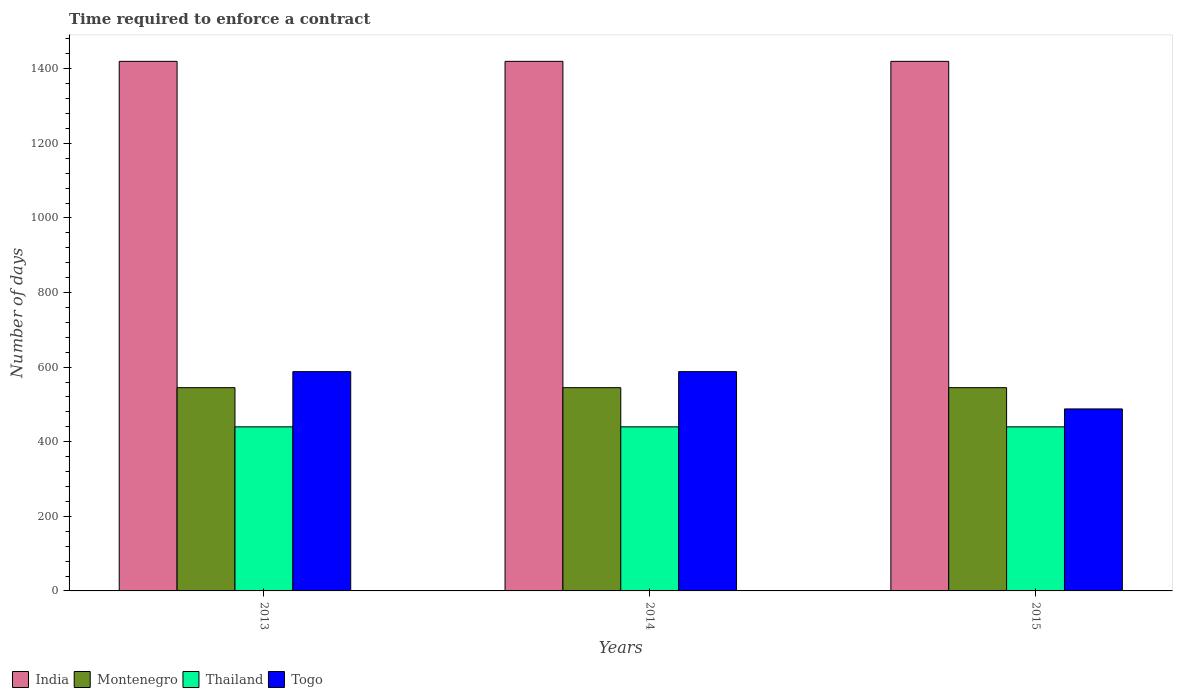How many groups of bars are there?
Your answer should be very brief. 3. Are the number of bars per tick equal to the number of legend labels?
Offer a very short reply. Yes. Are the number of bars on each tick of the X-axis equal?
Offer a very short reply. Yes. How many bars are there on the 3rd tick from the left?
Your response must be concise. 4. What is the label of the 3rd group of bars from the left?
Your answer should be compact. 2015. What is the number of days required to enforce a contract in India in 2015?
Ensure brevity in your answer.  1420. Across all years, what is the maximum number of days required to enforce a contract in Montenegro?
Your answer should be compact. 545. Across all years, what is the minimum number of days required to enforce a contract in Montenegro?
Make the answer very short. 545. In which year was the number of days required to enforce a contract in Thailand minimum?
Make the answer very short. 2013. What is the total number of days required to enforce a contract in India in the graph?
Ensure brevity in your answer.  4260. What is the difference between the number of days required to enforce a contract in Thailand in 2015 and the number of days required to enforce a contract in Togo in 2014?
Ensure brevity in your answer.  -148. What is the average number of days required to enforce a contract in Thailand per year?
Offer a very short reply. 440. In how many years, is the number of days required to enforce a contract in Togo greater than 1080 days?
Provide a short and direct response. 0. Is the number of days required to enforce a contract in Montenegro in 2013 less than that in 2014?
Make the answer very short. No. Is the difference between the number of days required to enforce a contract in Togo in 2013 and 2014 greater than the difference between the number of days required to enforce a contract in Montenegro in 2013 and 2014?
Provide a succinct answer. No. What is the difference between the highest and the lowest number of days required to enforce a contract in Montenegro?
Offer a very short reply. 0. In how many years, is the number of days required to enforce a contract in Thailand greater than the average number of days required to enforce a contract in Thailand taken over all years?
Offer a very short reply. 0. Is it the case that in every year, the sum of the number of days required to enforce a contract in Montenegro and number of days required to enforce a contract in Togo is greater than the sum of number of days required to enforce a contract in India and number of days required to enforce a contract in Thailand?
Make the answer very short. No. What does the 2nd bar from the left in 2013 represents?
Make the answer very short. Montenegro. What does the 2nd bar from the right in 2013 represents?
Keep it short and to the point. Thailand. Are all the bars in the graph horizontal?
Ensure brevity in your answer.  No. What is the difference between two consecutive major ticks on the Y-axis?
Keep it short and to the point. 200. Are the values on the major ticks of Y-axis written in scientific E-notation?
Offer a very short reply. No. Does the graph contain grids?
Provide a succinct answer. No. Where does the legend appear in the graph?
Provide a short and direct response. Bottom left. What is the title of the graph?
Provide a succinct answer. Time required to enforce a contract. What is the label or title of the X-axis?
Ensure brevity in your answer.  Years. What is the label or title of the Y-axis?
Your response must be concise. Number of days. What is the Number of days in India in 2013?
Make the answer very short. 1420. What is the Number of days of Montenegro in 2013?
Provide a short and direct response. 545. What is the Number of days in Thailand in 2013?
Offer a very short reply. 440. What is the Number of days in Togo in 2013?
Your answer should be very brief. 588. What is the Number of days of India in 2014?
Offer a terse response. 1420. What is the Number of days in Montenegro in 2014?
Your answer should be very brief. 545. What is the Number of days of Thailand in 2014?
Keep it short and to the point. 440. What is the Number of days in Togo in 2014?
Your answer should be very brief. 588. What is the Number of days in India in 2015?
Ensure brevity in your answer.  1420. What is the Number of days in Montenegro in 2015?
Offer a very short reply. 545. What is the Number of days in Thailand in 2015?
Make the answer very short. 440. What is the Number of days of Togo in 2015?
Offer a terse response. 488. Across all years, what is the maximum Number of days of India?
Your answer should be very brief. 1420. Across all years, what is the maximum Number of days of Montenegro?
Ensure brevity in your answer.  545. Across all years, what is the maximum Number of days in Thailand?
Your answer should be very brief. 440. Across all years, what is the maximum Number of days in Togo?
Make the answer very short. 588. Across all years, what is the minimum Number of days in India?
Ensure brevity in your answer.  1420. Across all years, what is the minimum Number of days of Montenegro?
Ensure brevity in your answer.  545. Across all years, what is the minimum Number of days in Thailand?
Offer a very short reply. 440. Across all years, what is the minimum Number of days in Togo?
Offer a very short reply. 488. What is the total Number of days of India in the graph?
Your answer should be very brief. 4260. What is the total Number of days of Montenegro in the graph?
Provide a succinct answer. 1635. What is the total Number of days of Thailand in the graph?
Give a very brief answer. 1320. What is the total Number of days of Togo in the graph?
Make the answer very short. 1664. What is the difference between the Number of days of India in 2013 and that in 2014?
Make the answer very short. 0. What is the difference between the Number of days of Thailand in 2013 and that in 2014?
Offer a very short reply. 0. What is the difference between the Number of days in Togo in 2013 and that in 2014?
Ensure brevity in your answer.  0. What is the difference between the Number of days in Montenegro in 2013 and that in 2015?
Your answer should be compact. 0. What is the difference between the Number of days of Togo in 2013 and that in 2015?
Your answer should be very brief. 100. What is the difference between the Number of days of India in 2014 and that in 2015?
Provide a short and direct response. 0. What is the difference between the Number of days of Togo in 2014 and that in 2015?
Offer a terse response. 100. What is the difference between the Number of days in India in 2013 and the Number of days in Montenegro in 2014?
Your answer should be very brief. 875. What is the difference between the Number of days in India in 2013 and the Number of days in Thailand in 2014?
Your answer should be compact. 980. What is the difference between the Number of days of India in 2013 and the Number of days of Togo in 2014?
Ensure brevity in your answer.  832. What is the difference between the Number of days in Montenegro in 2013 and the Number of days in Thailand in 2014?
Provide a succinct answer. 105. What is the difference between the Number of days of Montenegro in 2013 and the Number of days of Togo in 2014?
Your answer should be very brief. -43. What is the difference between the Number of days in Thailand in 2013 and the Number of days in Togo in 2014?
Offer a terse response. -148. What is the difference between the Number of days in India in 2013 and the Number of days in Montenegro in 2015?
Give a very brief answer. 875. What is the difference between the Number of days of India in 2013 and the Number of days of Thailand in 2015?
Keep it short and to the point. 980. What is the difference between the Number of days in India in 2013 and the Number of days in Togo in 2015?
Ensure brevity in your answer.  932. What is the difference between the Number of days of Montenegro in 2013 and the Number of days of Thailand in 2015?
Offer a very short reply. 105. What is the difference between the Number of days in Thailand in 2013 and the Number of days in Togo in 2015?
Your answer should be compact. -48. What is the difference between the Number of days in India in 2014 and the Number of days in Montenegro in 2015?
Make the answer very short. 875. What is the difference between the Number of days of India in 2014 and the Number of days of Thailand in 2015?
Provide a short and direct response. 980. What is the difference between the Number of days in India in 2014 and the Number of days in Togo in 2015?
Your answer should be very brief. 932. What is the difference between the Number of days of Montenegro in 2014 and the Number of days of Thailand in 2015?
Your answer should be compact. 105. What is the difference between the Number of days of Thailand in 2014 and the Number of days of Togo in 2015?
Provide a succinct answer. -48. What is the average Number of days in India per year?
Provide a succinct answer. 1420. What is the average Number of days in Montenegro per year?
Provide a short and direct response. 545. What is the average Number of days of Thailand per year?
Keep it short and to the point. 440. What is the average Number of days in Togo per year?
Give a very brief answer. 554.67. In the year 2013, what is the difference between the Number of days of India and Number of days of Montenegro?
Ensure brevity in your answer.  875. In the year 2013, what is the difference between the Number of days in India and Number of days in Thailand?
Offer a very short reply. 980. In the year 2013, what is the difference between the Number of days of India and Number of days of Togo?
Provide a short and direct response. 832. In the year 2013, what is the difference between the Number of days of Montenegro and Number of days of Thailand?
Make the answer very short. 105. In the year 2013, what is the difference between the Number of days in Montenegro and Number of days in Togo?
Make the answer very short. -43. In the year 2013, what is the difference between the Number of days of Thailand and Number of days of Togo?
Your answer should be compact. -148. In the year 2014, what is the difference between the Number of days of India and Number of days of Montenegro?
Your answer should be compact. 875. In the year 2014, what is the difference between the Number of days in India and Number of days in Thailand?
Ensure brevity in your answer.  980. In the year 2014, what is the difference between the Number of days in India and Number of days in Togo?
Provide a short and direct response. 832. In the year 2014, what is the difference between the Number of days in Montenegro and Number of days in Thailand?
Provide a short and direct response. 105. In the year 2014, what is the difference between the Number of days in Montenegro and Number of days in Togo?
Offer a very short reply. -43. In the year 2014, what is the difference between the Number of days of Thailand and Number of days of Togo?
Give a very brief answer. -148. In the year 2015, what is the difference between the Number of days in India and Number of days in Montenegro?
Your answer should be compact. 875. In the year 2015, what is the difference between the Number of days of India and Number of days of Thailand?
Offer a terse response. 980. In the year 2015, what is the difference between the Number of days of India and Number of days of Togo?
Your answer should be very brief. 932. In the year 2015, what is the difference between the Number of days in Montenegro and Number of days in Thailand?
Offer a very short reply. 105. In the year 2015, what is the difference between the Number of days of Thailand and Number of days of Togo?
Your answer should be compact. -48. What is the ratio of the Number of days of Montenegro in 2013 to that in 2014?
Your response must be concise. 1. What is the ratio of the Number of days in India in 2013 to that in 2015?
Your answer should be very brief. 1. What is the ratio of the Number of days of Montenegro in 2013 to that in 2015?
Give a very brief answer. 1. What is the ratio of the Number of days of Thailand in 2013 to that in 2015?
Keep it short and to the point. 1. What is the ratio of the Number of days of Togo in 2013 to that in 2015?
Provide a short and direct response. 1.2. What is the ratio of the Number of days in India in 2014 to that in 2015?
Provide a succinct answer. 1. What is the ratio of the Number of days in Montenegro in 2014 to that in 2015?
Provide a succinct answer. 1. What is the ratio of the Number of days in Togo in 2014 to that in 2015?
Offer a very short reply. 1.2. What is the difference between the highest and the second highest Number of days of India?
Provide a succinct answer. 0. What is the difference between the highest and the second highest Number of days in Thailand?
Your answer should be very brief. 0. What is the difference between the highest and the lowest Number of days in India?
Provide a succinct answer. 0. What is the difference between the highest and the lowest Number of days of Montenegro?
Offer a terse response. 0. What is the difference between the highest and the lowest Number of days in Thailand?
Your answer should be very brief. 0. 